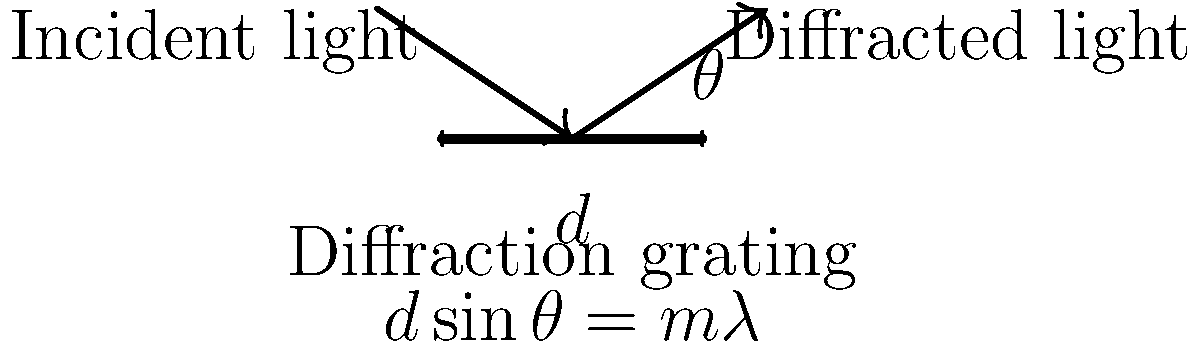In a performance testing scenario for a spectroscopy application, you're using a diffraction grating with 5000 lines/cm to analyze light. The first-order maximum (m=1) is observed at an angle of 30°. Calculate the wavelength of the light being analyzed, given that $\sin 30° = 0.5$. How would you optimize the code to handle multiple wavelength calculations efficiently? Let's approach this step-by-step:

1. Identify the given information:
   - Diffraction grating: 5000 lines/cm
   - First-order maximum (m = 1)
   - Angle of diffraction (θ) = 30°
   - $\sin 30° = 0.5$

2. Calculate the grating spacing (d):
   $$d = \frac{1}{5000 \text{ lines/cm}} = 2 \times 10^{-4} \text{ cm} = 2000 \text{ nm}$$

3. Use the diffraction grating equation:
   $$d \sin \theta = m\lambda$$

4. Substitute the known values:
   $$(2000 \text{ nm}) \cdot (0.5) = 1 \cdot \lambda$$

5. Solve for λ:
   $$\lambda = 1000 \text{ nm} = 1 \times 10^{-6} \text{ m}$$

For optimizing code to handle multiple wavelength calculations efficiently:

1. Use Scala's parallel collections to perform calculations concurrently.
2. Implement memoization to cache results for frequently used angle values.
3. Use lazy evaluation for intermediate results to avoid unnecessary computations.
4. Consider using specialized numeric types like `spire.math.Numeric` for improved performance in numeric calculations.
5. Implement tail recursion for iterative calculations to optimize stack usage.
Answer: 1000 nm 